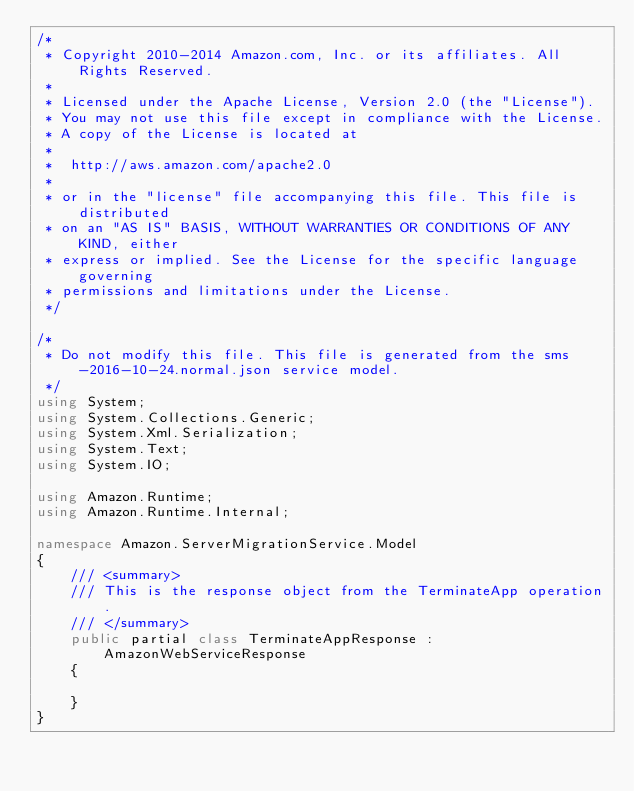<code> <loc_0><loc_0><loc_500><loc_500><_C#_>/*
 * Copyright 2010-2014 Amazon.com, Inc. or its affiliates. All Rights Reserved.
 * 
 * Licensed under the Apache License, Version 2.0 (the "License").
 * You may not use this file except in compliance with the License.
 * A copy of the License is located at
 * 
 *  http://aws.amazon.com/apache2.0
 * 
 * or in the "license" file accompanying this file. This file is distributed
 * on an "AS IS" BASIS, WITHOUT WARRANTIES OR CONDITIONS OF ANY KIND, either
 * express or implied. See the License for the specific language governing
 * permissions and limitations under the License.
 */

/*
 * Do not modify this file. This file is generated from the sms-2016-10-24.normal.json service model.
 */
using System;
using System.Collections.Generic;
using System.Xml.Serialization;
using System.Text;
using System.IO;

using Amazon.Runtime;
using Amazon.Runtime.Internal;

namespace Amazon.ServerMigrationService.Model
{
    /// <summary>
    /// This is the response object from the TerminateApp operation.
    /// </summary>
    public partial class TerminateAppResponse : AmazonWebServiceResponse
    {

    }
}</code> 